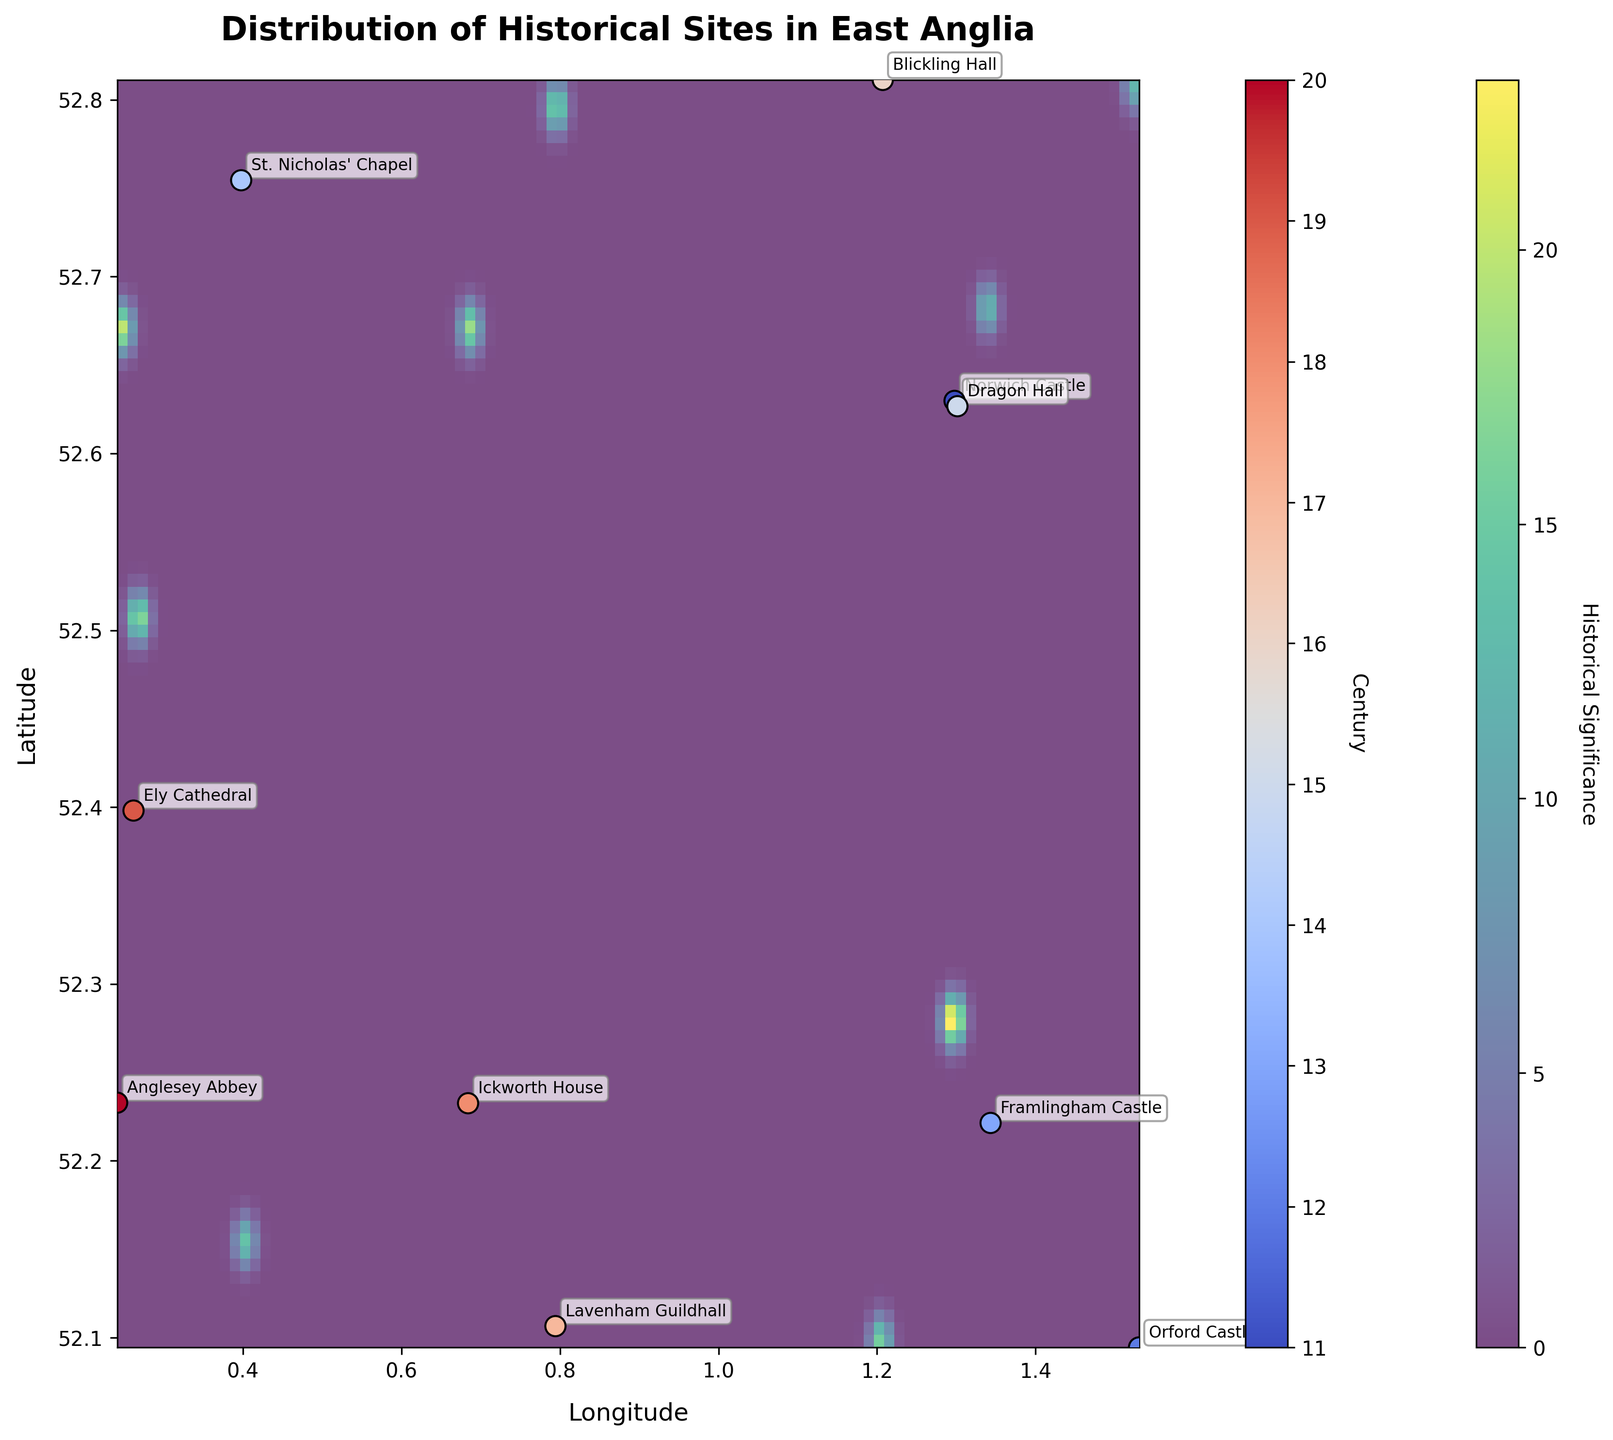What is the title of the plot? The title is typically located at the top of the plot. It provides a summary of what the plot represents.
Answer: Distribution of Historical Sites in East Anglia Which century has its sites marked with the highest color intensity? The highest color intensity on the scatter plot indicates the sites from the 20th century, as represented by the color bar.
Answer: 20th century How many historical sites are marked on the map? Each data point represents a historical site, and you can count them directly from the scatter plot.
Answer: 10 What is the general trend of historical sites based on latitude and longitude? By observing the scatter of points and their annotations, one can deduce any clustering or spread of historical sites over centuries.
Answer: They are fairly spread out across East Anglia with no obvious clustering Which historical site is located at the highest latitude? By looking at the latitude values on the Y-axis, the site at the highest point corresponds to its respective annotation.
Answer: St. Nicholas' Chapel Which historical site is located at the lowest longitude? By examining the X-axis, the site at the furthest left corresponds to the lowest longitude.
Answer: Anglesey Abbey How does the density of historical sites change across centuries? Observing the heatmap color variations across different centuries visualized through the color bar indicates historical significance changes.
Answer: Density varies with some centuries having more dispersed sites Which two centuries' sites are closest to each other in location? This involves comparing the geographical positions (latitude and longitude) of the sites across different centuries for their proximity.
Answer: 11th (Norwich Castle) and 15th (Dragon Hall) What color is used to represent historical significance on the heatmap? The heatmap uses different color intensities to indicate historical significance. Observing the legend will give this information.
Answer: Viridis (gradient from blue to yellow) Which site represents the 13th century and at what coordinates is it located? By checking the annotations and the century color of the scatter points, one can identify the site and its respective coordinates.
Answer: Framlingham Castle at (52.221410, 1.343205) 